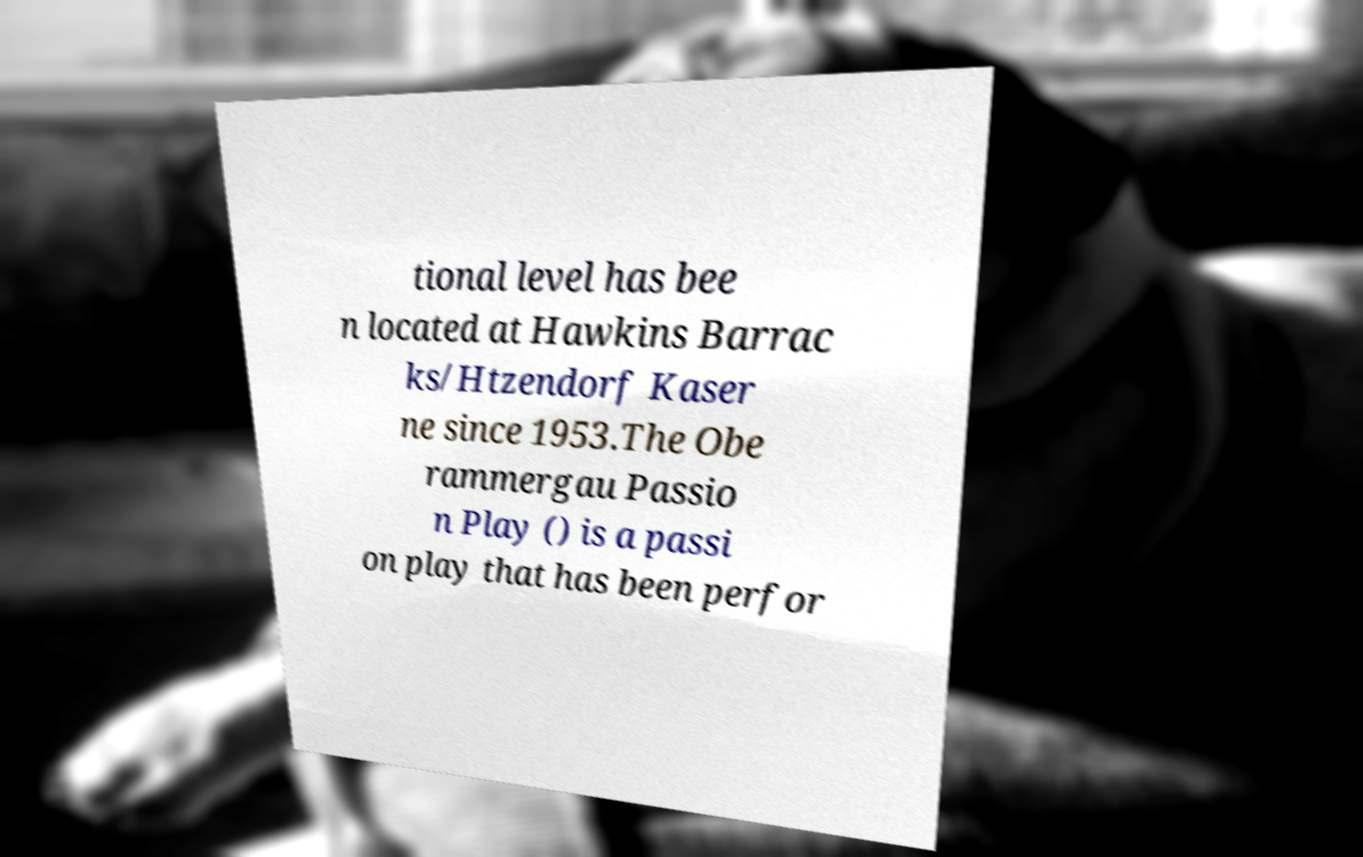There's text embedded in this image that I need extracted. Can you transcribe it verbatim? tional level has bee n located at Hawkins Barrac ks/Htzendorf Kaser ne since 1953.The Obe rammergau Passio n Play () is a passi on play that has been perfor 